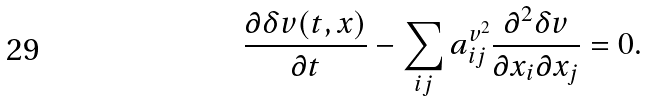<formula> <loc_0><loc_0><loc_500><loc_500>\frac { \partial \delta v ( t , x ) } { \partial t } - \sum _ { i j } a ^ { v ^ { 2 } } _ { i j } \frac { \partial ^ { 2 } \delta v } { \partial x _ { i } \partial x _ { j } } = 0 .</formula> 